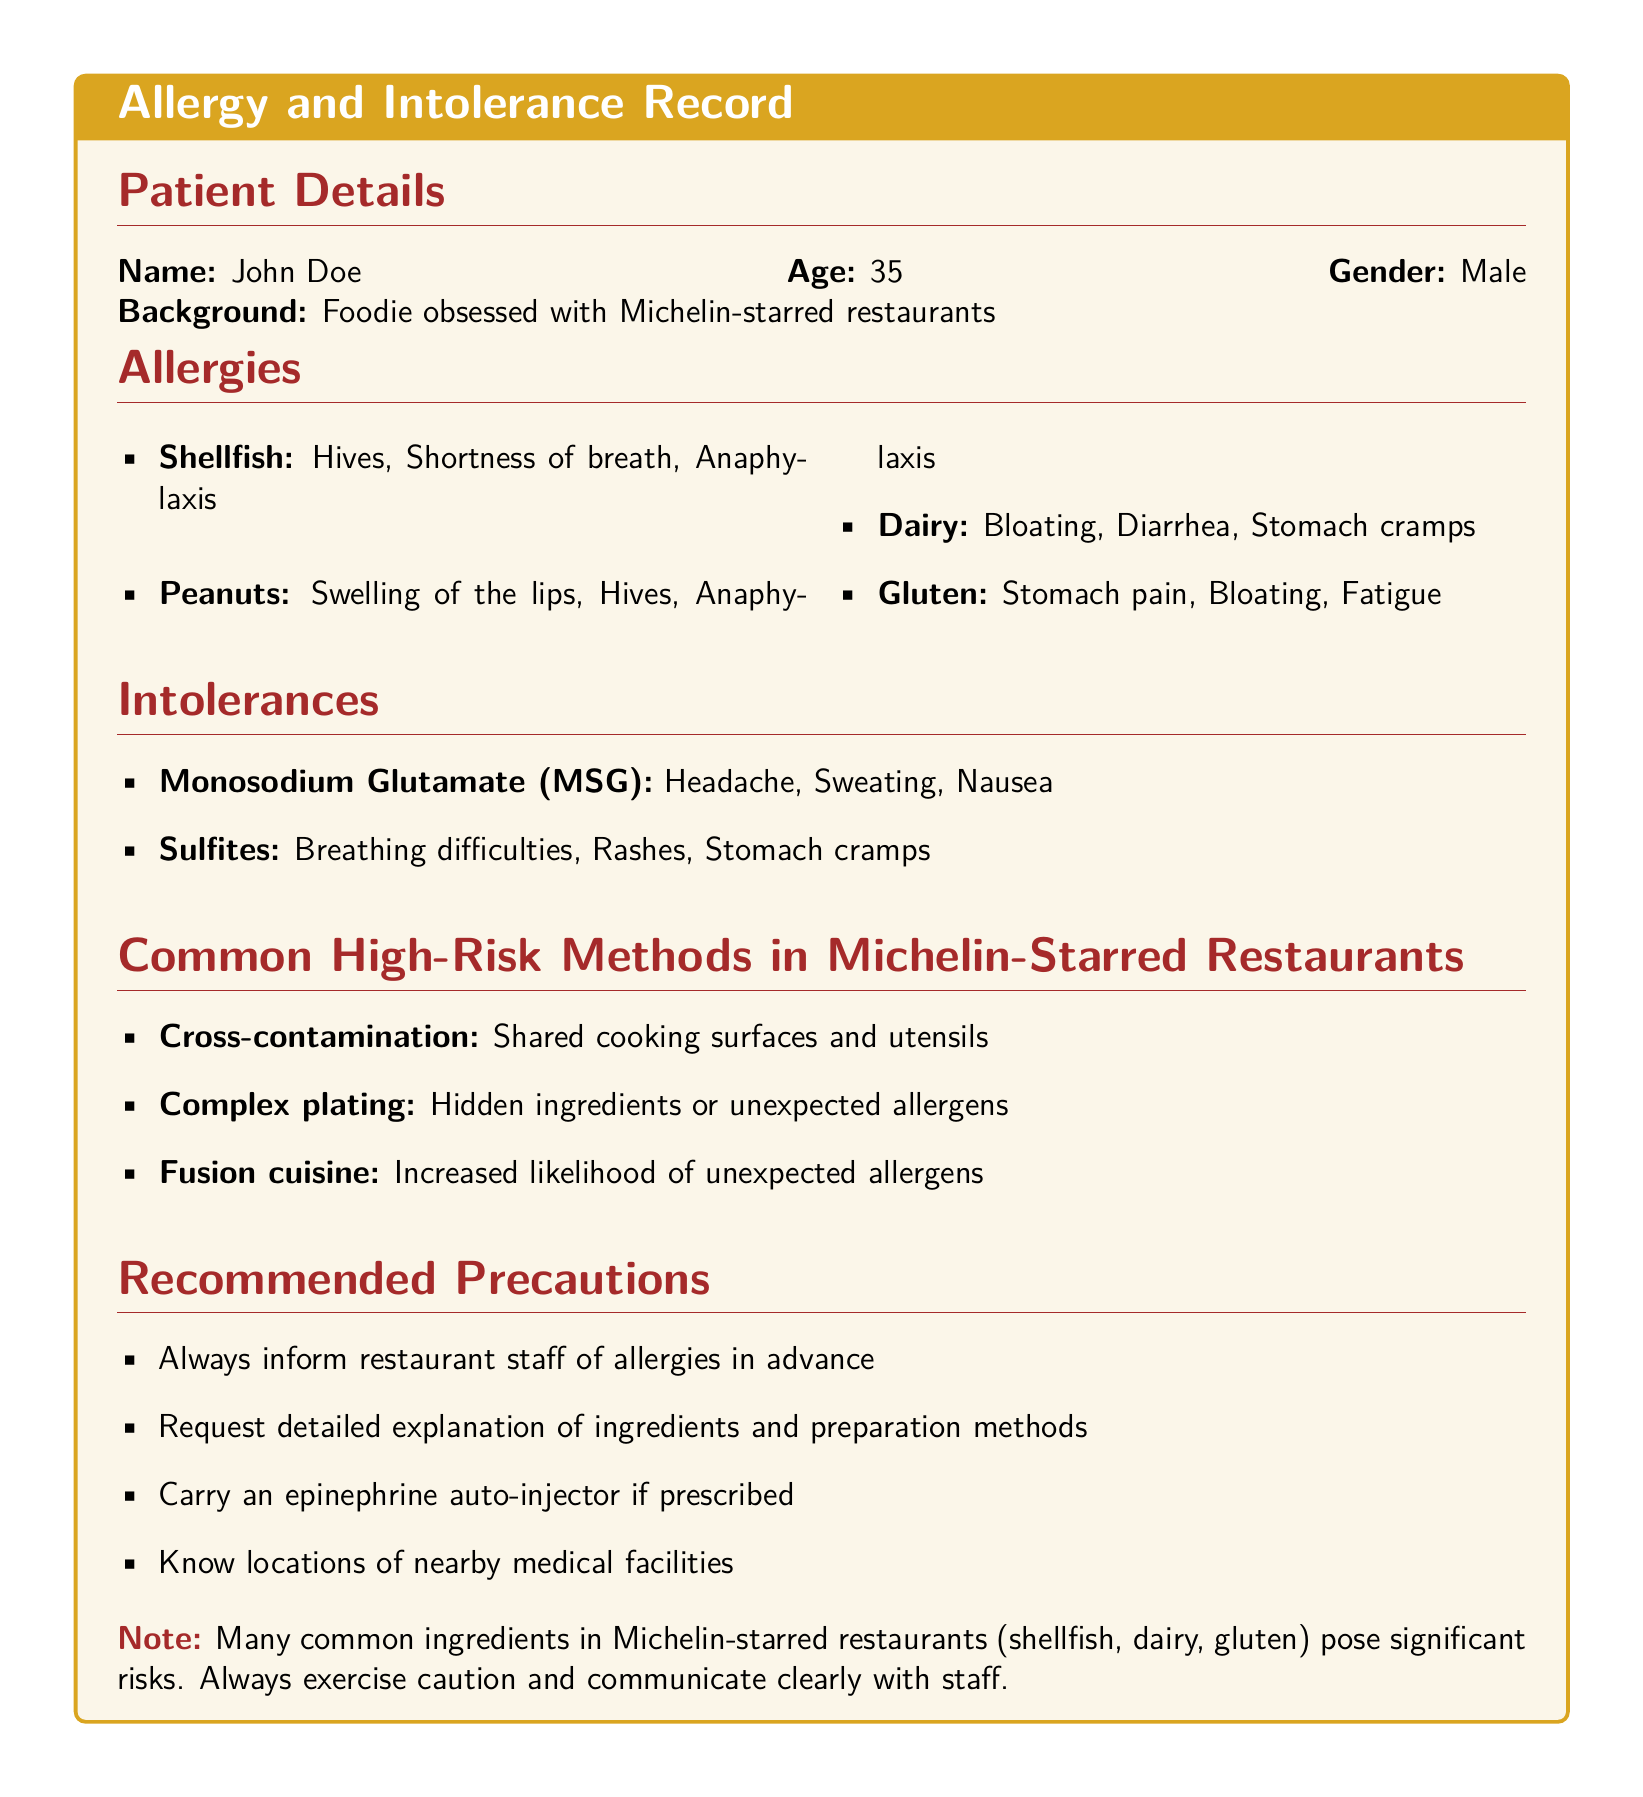What is the patient's name? The patient's name is explicitly mentioned in the document under Patient Details.
Answer: John Doe What age is the patient? The patient's age is stated alongside their name in the Patient Details section.
Answer: 35 What allergy causes hives and shortness of breath? This allergy is listed in the Allergies section, detailing its symptoms.
Answer: Shellfish Which food intolerance is associated with headaches? This intolerance is specified under the Intolerances section, along with its symptoms.
Answer: Monosodium Glutamate (MSG) What is a recommended precaution for dining at restaurants? This precaution is mentioned in the Recommended Precautions section to mitigate risks associated with allergies.
Answer: Inform restaurant staff of allergies in advance What cooking method increases the likelihood of unexpected allergens? This method is identified in the Common High-Risk Methods section of the document.
Answer: Fusion cuisine How many food allergies are listed in the document? The total number of food allergies can be counted in the Allergies section.
Answer: Four What is a significant risk associated with Michelin-starred restaurants? The risks are detailed in the Note section, emphasizing common allergens present in their dishes.
Answer: Shellfish What is the primary purpose of carrying an epinephrine auto-injector? The purpose is inferred from the recommended precautions for managing severe allergic reactions.
Answer: To treat anaphylaxis 